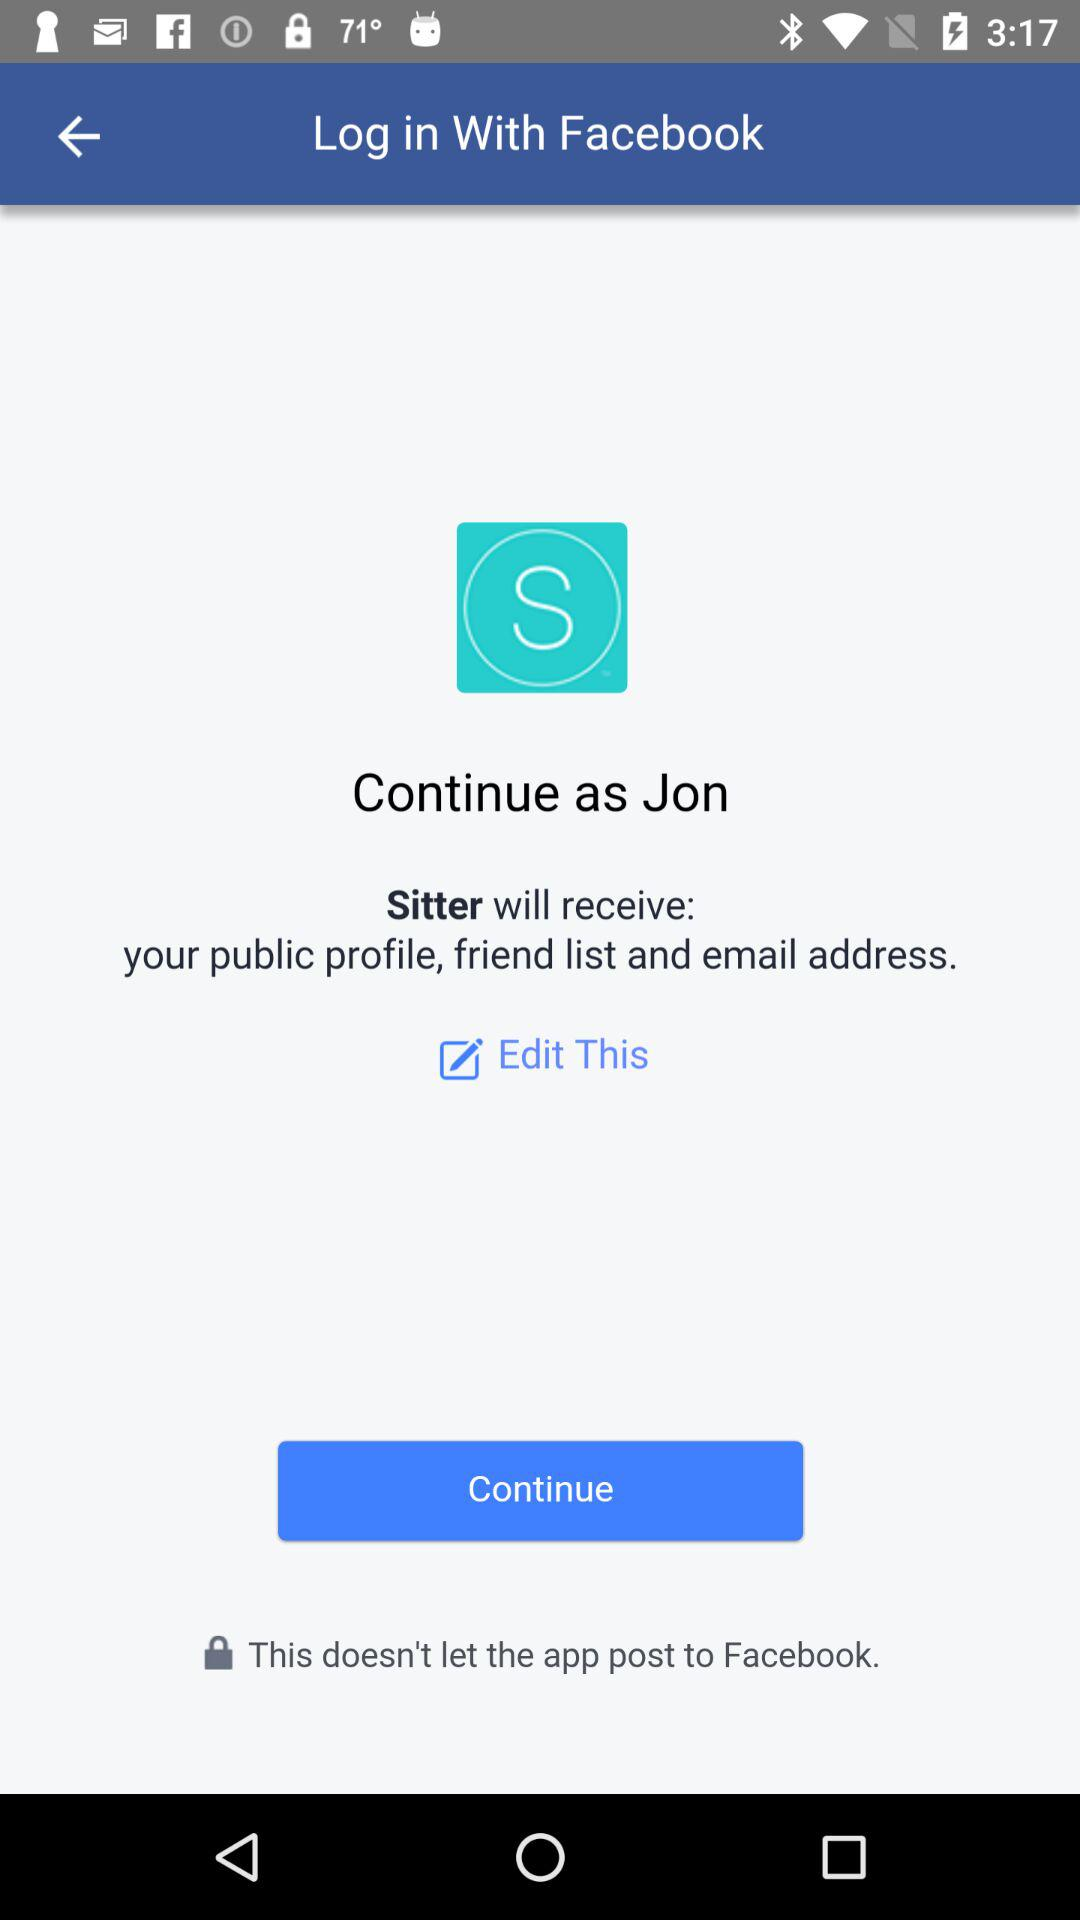What application is asking for permission? The application asking for permission is "Sitter". 